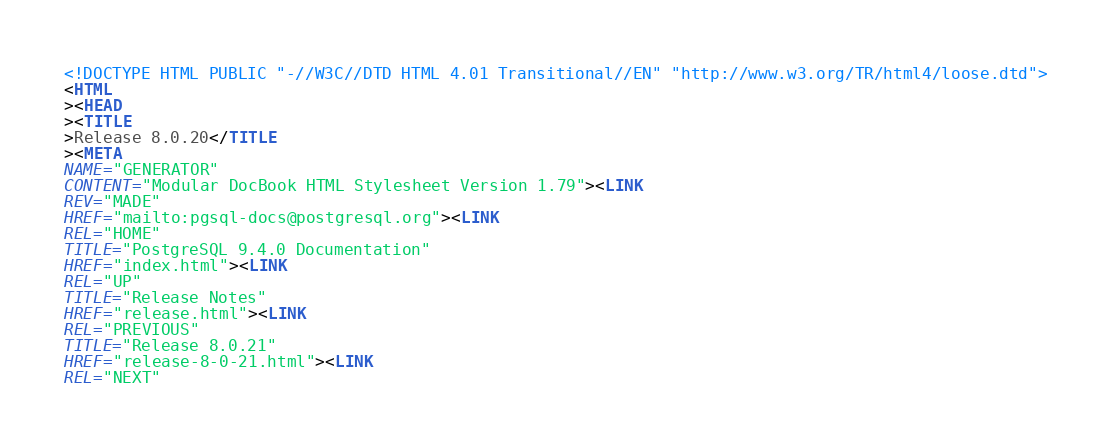Convert code to text. <code><loc_0><loc_0><loc_500><loc_500><_HTML_><!DOCTYPE HTML PUBLIC "-//W3C//DTD HTML 4.01 Transitional//EN" "http://www.w3.org/TR/html4/loose.dtd">
<HTML
><HEAD
><TITLE
>Release 8.0.20</TITLE
><META
NAME="GENERATOR"
CONTENT="Modular DocBook HTML Stylesheet Version 1.79"><LINK
REV="MADE"
HREF="mailto:pgsql-docs@postgresql.org"><LINK
REL="HOME"
TITLE="PostgreSQL 9.4.0 Documentation"
HREF="index.html"><LINK
REL="UP"
TITLE="Release Notes"
HREF="release.html"><LINK
REL="PREVIOUS"
TITLE="Release 8.0.21"
HREF="release-8-0-21.html"><LINK
REL="NEXT"</code> 